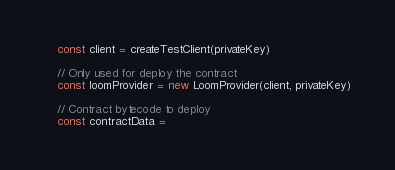Convert code to text. <code><loc_0><loc_0><loc_500><loc_500><_TypeScript_>    const client = createTestClient(privateKey)

    // Only used for deploy the contract
    const loomProvider = new LoomProvider(client, privateKey)

    // Contract bytecode to deploy
    const contractData =</code> 